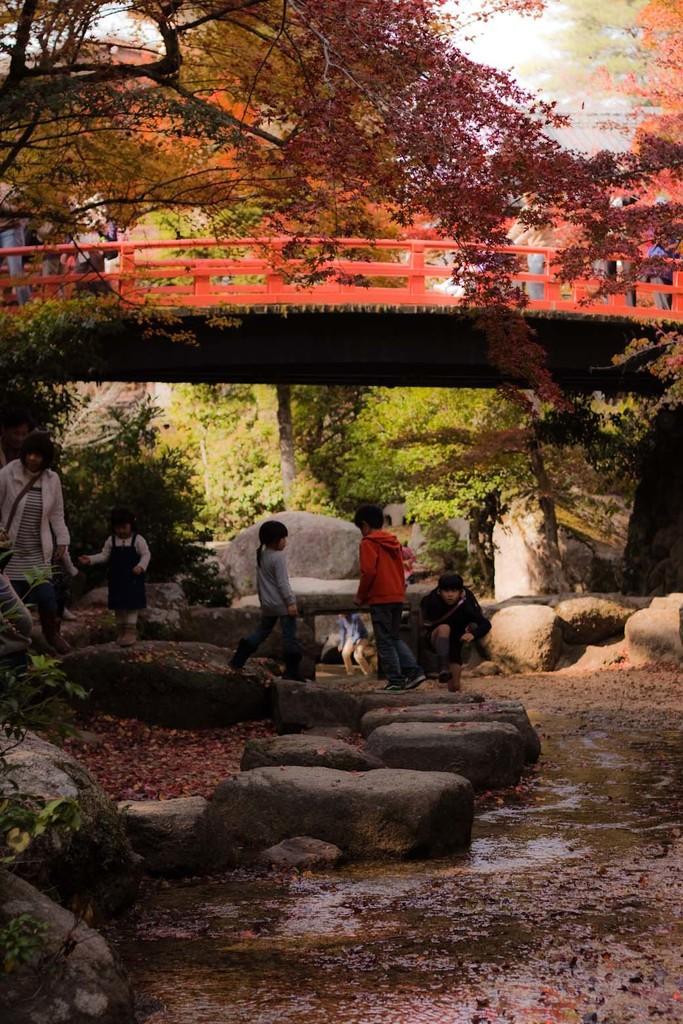Describe this image in one or two sentences. In this image we can see some people standing under the bridge. We can also see some stones, water and the trees. 